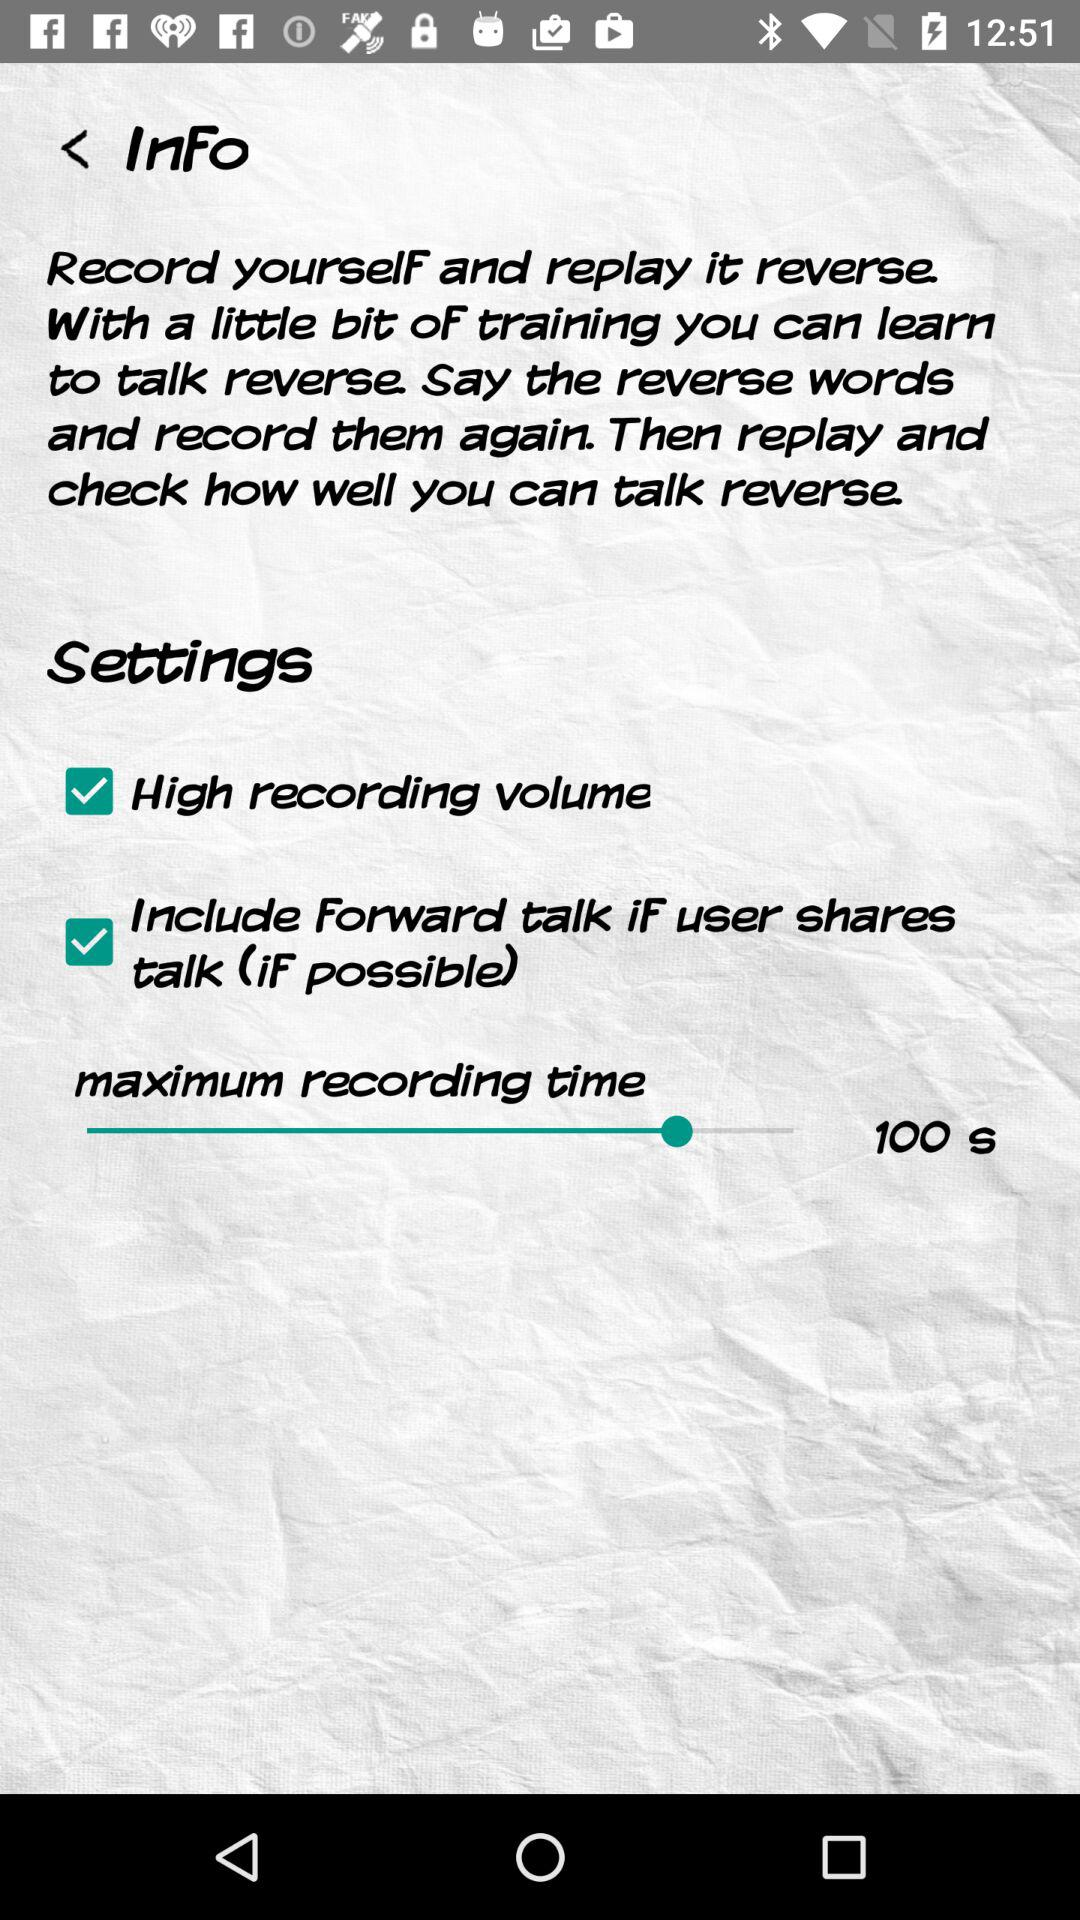How many check boxes are there in the settings?
Answer the question using a single word or phrase. 2 